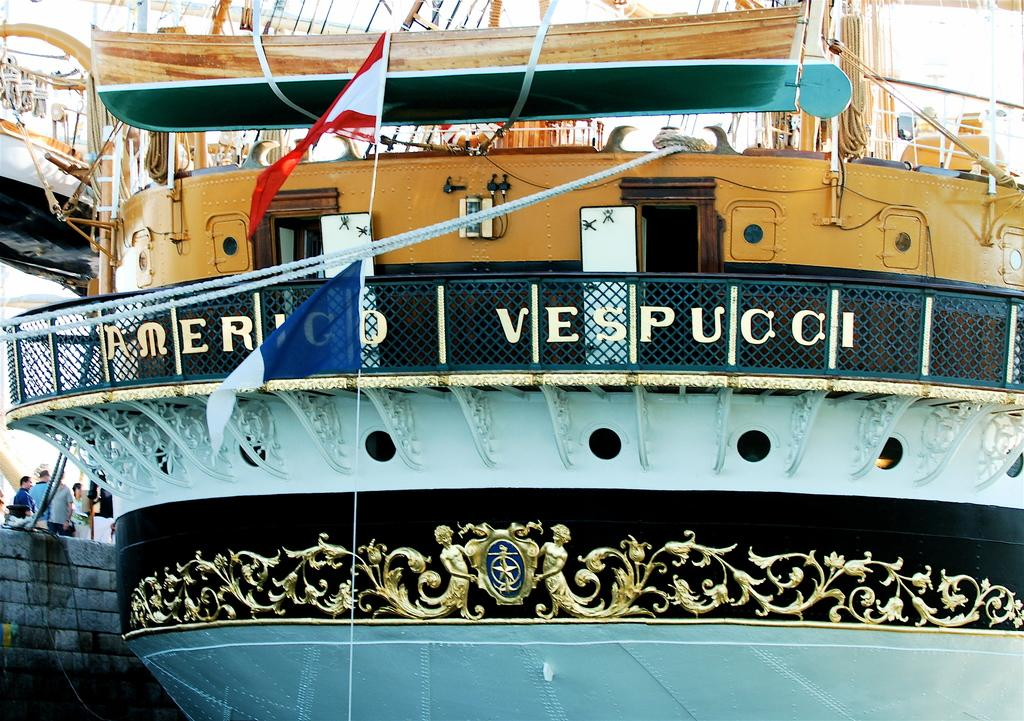What is the main subject of the image? The main subject of the image is a ship. Are there any people in the image? Yes, there are people near the ship. What else can be seen in the image besides the ship and people? Flags are visible in the image. What type of wine is being served on the ship in the image? There is no wine present in the image; it only features a ship, people, and flags. Can you describe the brain activity of the people on the ship in the image? There is no information about the brain activity of the people in the image, as it only shows their physical presence near the ship. 